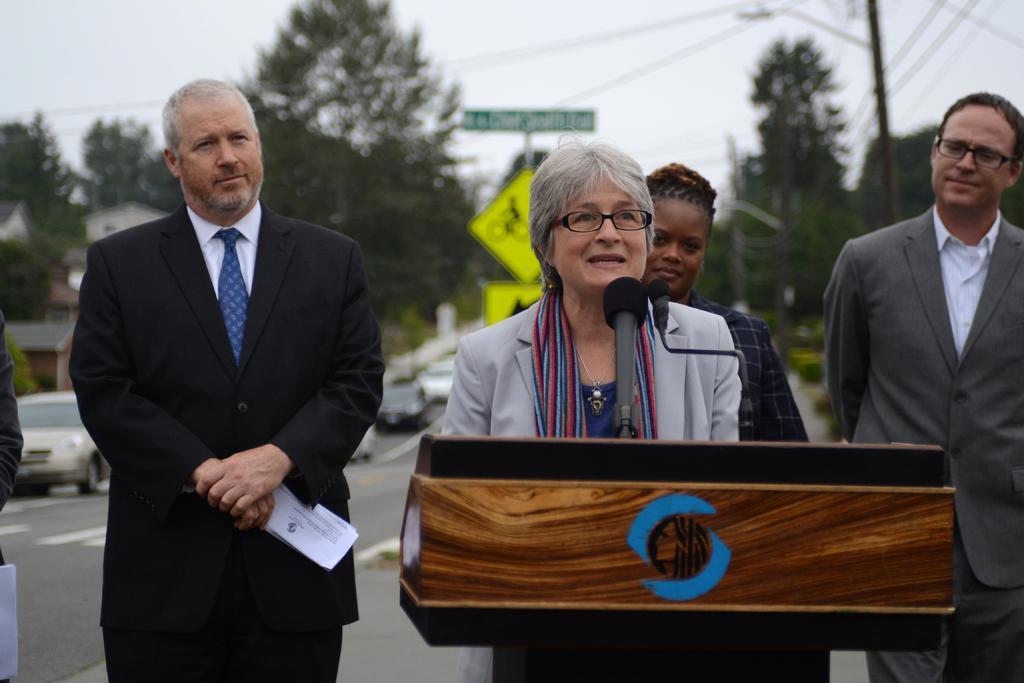Please provide a concise description of this image. In this image there are four personś, one person is holding an object, another person is talking, there is a microphone, there are trees, there is a pole, there is a streetlight, there are wireś, there is sky, towardś the left of the image there is a car, there is road, there are houses. 